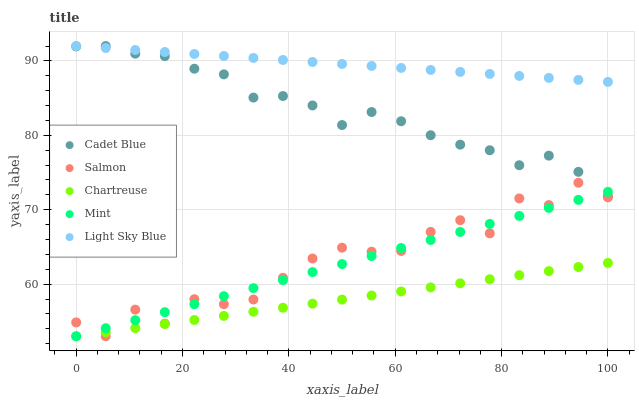Does Chartreuse have the minimum area under the curve?
Answer yes or no. Yes. Does Light Sky Blue have the maximum area under the curve?
Answer yes or no. Yes. Does Cadet Blue have the minimum area under the curve?
Answer yes or no. No. Does Cadet Blue have the maximum area under the curve?
Answer yes or no. No. Is Chartreuse the smoothest?
Answer yes or no. Yes. Is Salmon the roughest?
Answer yes or no. Yes. Is Cadet Blue the smoothest?
Answer yes or no. No. Is Cadet Blue the roughest?
Answer yes or no. No. Does Mint have the lowest value?
Answer yes or no. Yes. Does Cadet Blue have the lowest value?
Answer yes or no. No. Does Light Sky Blue have the highest value?
Answer yes or no. Yes. Does Chartreuse have the highest value?
Answer yes or no. No. Is Salmon less than Light Sky Blue?
Answer yes or no. Yes. Is Cadet Blue greater than Salmon?
Answer yes or no. Yes. Does Cadet Blue intersect Light Sky Blue?
Answer yes or no. Yes. Is Cadet Blue less than Light Sky Blue?
Answer yes or no. No. Is Cadet Blue greater than Light Sky Blue?
Answer yes or no. No. Does Salmon intersect Light Sky Blue?
Answer yes or no. No. 